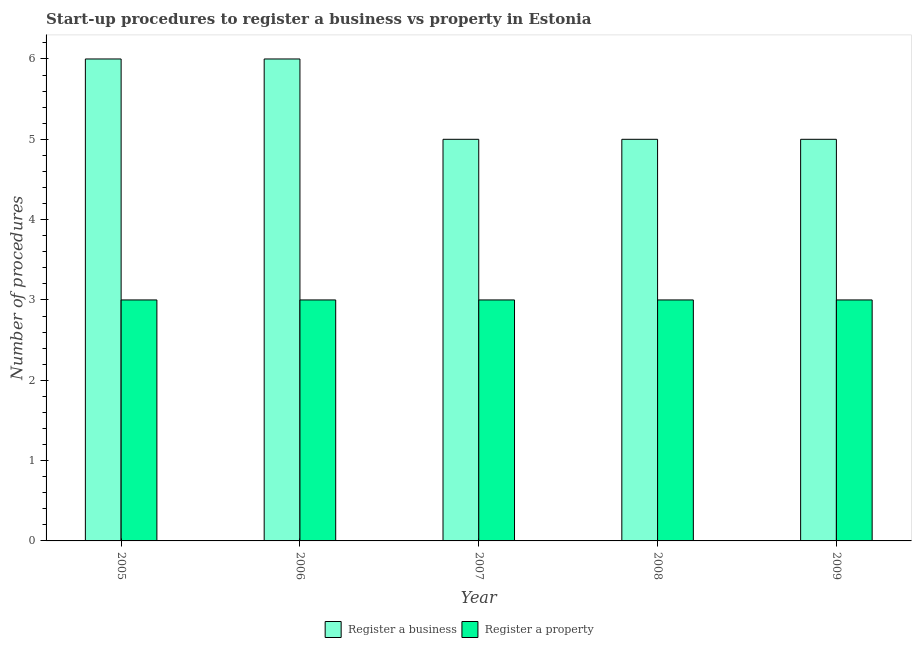Are the number of bars per tick equal to the number of legend labels?
Give a very brief answer. Yes. Are the number of bars on each tick of the X-axis equal?
Provide a short and direct response. Yes. In how many cases, is the number of bars for a given year not equal to the number of legend labels?
Provide a short and direct response. 0. What is the number of procedures to register a business in 2006?
Give a very brief answer. 6. Across all years, what is the maximum number of procedures to register a property?
Give a very brief answer. 3. Across all years, what is the minimum number of procedures to register a property?
Your response must be concise. 3. What is the total number of procedures to register a property in the graph?
Provide a short and direct response. 15. What is the difference between the number of procedures to register a business in 2006 and the number of procedures to register a property in 2007?
Your answer should be very brief. 1. What is the average number of procedures to register a property per year?
Your response must be concise. 3. In the year 2009, what is the difference between the number of procedures to register a business and number of procedures to register a property?
Keep it short and to the point. 0. Is the number of procedures to register a business in 2008 less than that in 2009?
Offer a terse response. No. Is the difference between the number of procedures to register a property in 2005 and 2007 greater than the difference between the number of procedures to register a business in 2005 and 2007?
Your answer should be compact. No. What is the difference between the highest and the lowest number of procedures to register a business?
Your response must be concise. 1. In how many years, is the number of procedures to register a property greater than the average number of procedures to register a property taken over all years?
Provide a succinct answer. 0. What does the 1st bar from the left in 2006 represents?
Give a very brief answer. Register a business. What does the 1st bar from the right in 2005 represents?
Give a very brief answer. Register a property. Are the values on the major ticks of Y-axis written in scientific E-notation?
Make the answer very short. No. Does the graph contain any zero values?
Keep it short and to the point. No. Does the graph contain grids?
Ensure brevity in your answer.  No. Where does the legend appear in the graph?
Offer a very short reply. Bottom center. How many legend labels are there?
Give a very brief answer. 2. What is the title of the graph?
Make the answer very short. Start-up procedures to register a business vs property in Estonia. What is the label or title of the X-axis?
Ensure brevity in your answer.  Year. What is the label or title of the Y-axis?
Give a very brief answer. Number of procedures. What is the Number of procedures in Register a business in 2005?
Your answer should be compact. 6. What is the Number of procedures of Register a property in 2005?
Offer a terse response. 3. What is the Number of procedures of Register a business in 2006?
Provide a short and direct response. 6. What is the Number of procedures of Register a property in 2006?
Your response must be concise. 3. What is the Number of procedures in Register a property in 2007?
Offer a very short reply. 3. What is the Number of procedures in Register a business in 2008?
Make the answer very short. 5. What is the Number of procedures of Register a property in 2009?
Offer a very short reply. 3. Across all years, what is the maximum Number of procedures of Register a property?
Your answer should be very brief. 3. Across all years, what is the minimum Number of procedures in Register a business?
Keep it short and to the point. 5. What is the total Number of procedures in Register a business in the graph?
Your answer should be very brief. 27. What is the total Number of procedures in Register a property in the graph?
Provide a succinct answer. 15. What is the difference between the Number of procedures in Register a property in 2005 and that in 2006?
Your response must be concise. 0. What is the difference between the Number of procedures in Register a business in 2005 and that in 2007?
Make the answer very short. 1. What is the difference between the Number of procedures of Register a property in 2005 and that in 2007?
Your response must be concise. 0. What is the difference between the Number of procedures in Register a property in 2005 and that in 2008?
Your answer should be compact. 0. What is the difference between the Number of procedures of Register a business in 2005 and that in 2009?
Keep it short and to the point. 1. What is the difference between the Number of procedures of Register a property in 2005 and that in 2009?
Provide a succinct answer. 0. What is the difference between the Number of procedures of Register a property in 2007 and that in 2008?
Your answer should be compact. 0. What is the difference between the Number of procedures in Register a business in 2008 and that in 2009?
Offer a terse response. 0. What is the difference between the Number of procedures of Register a business in 2005 and the Number of procedures of Register a property in 2006?
Offer a terse response. 3. What is the difference between the Number of procedures in Register a business in 2006 and the Number of procedures in Register a property in 2008?
Your response must be concise. 3. What is the difference between the Number of procedures of Register a business in 2006 and the Number of procedures of Register a property in 2009?
Provide a short and direct response. 3. What is the difference between the Number of procedures of Register a business in 2007 and the Number of procedures of Register a property in 2009?
Make the answer very short. 2. In the year 2005, what is the difference between the Number of procedures of Register a business and Number of procedures of Register a property?
Provide a succinct answer. 3. In the year 2006, what is the difference between the Number of procedures of Register a business and Number of procedures of Register a property?
Your answer should be very brief. 3. What is the ratio of the Number of procedures of Register a business in 2005 to that in 2007?
Offer a very short reply. 1.2. What is the ratio of the Number of procedures of Register a property in 2005 to that in 2007?
Offer a very short reply. 1. What is the ratio of the Number of procedures in Register a business in 2005 to that in 2009?
Keep it short and to the point. 1.2. What is the ratio of the Number of procedures of Register a business in 2006 to that in 2007?
Keep it short and to the point. 1.2. What is the ratio of the Number of procedures in Register a property in 2006 to that in 2007?
Provide a succinct answer. 1. What is the ratio of the Number of procedures in Register a business in 2006 to that in 2008?
Offer a terse response. 1.2. What is the ratio of the Number of procedures in Register a business in 2007 to that in 2009?
Give a very brief answer. 1. What is the ratio of the Number of procedures of Register a property in 2008 to that in 2009?
Your answer should be very brief. 1. What is the difference between the highest and the second highest Number of procedures of Register a business?
Your answer should be very brief. 0. What is the difference between the highest and the second highest Number of procedures of Register a property?
Your answer should be very brief. 0. What is the difference between the highest and the lowest Number of procedures of Register a property?
Provide a short and direct response. 0. 